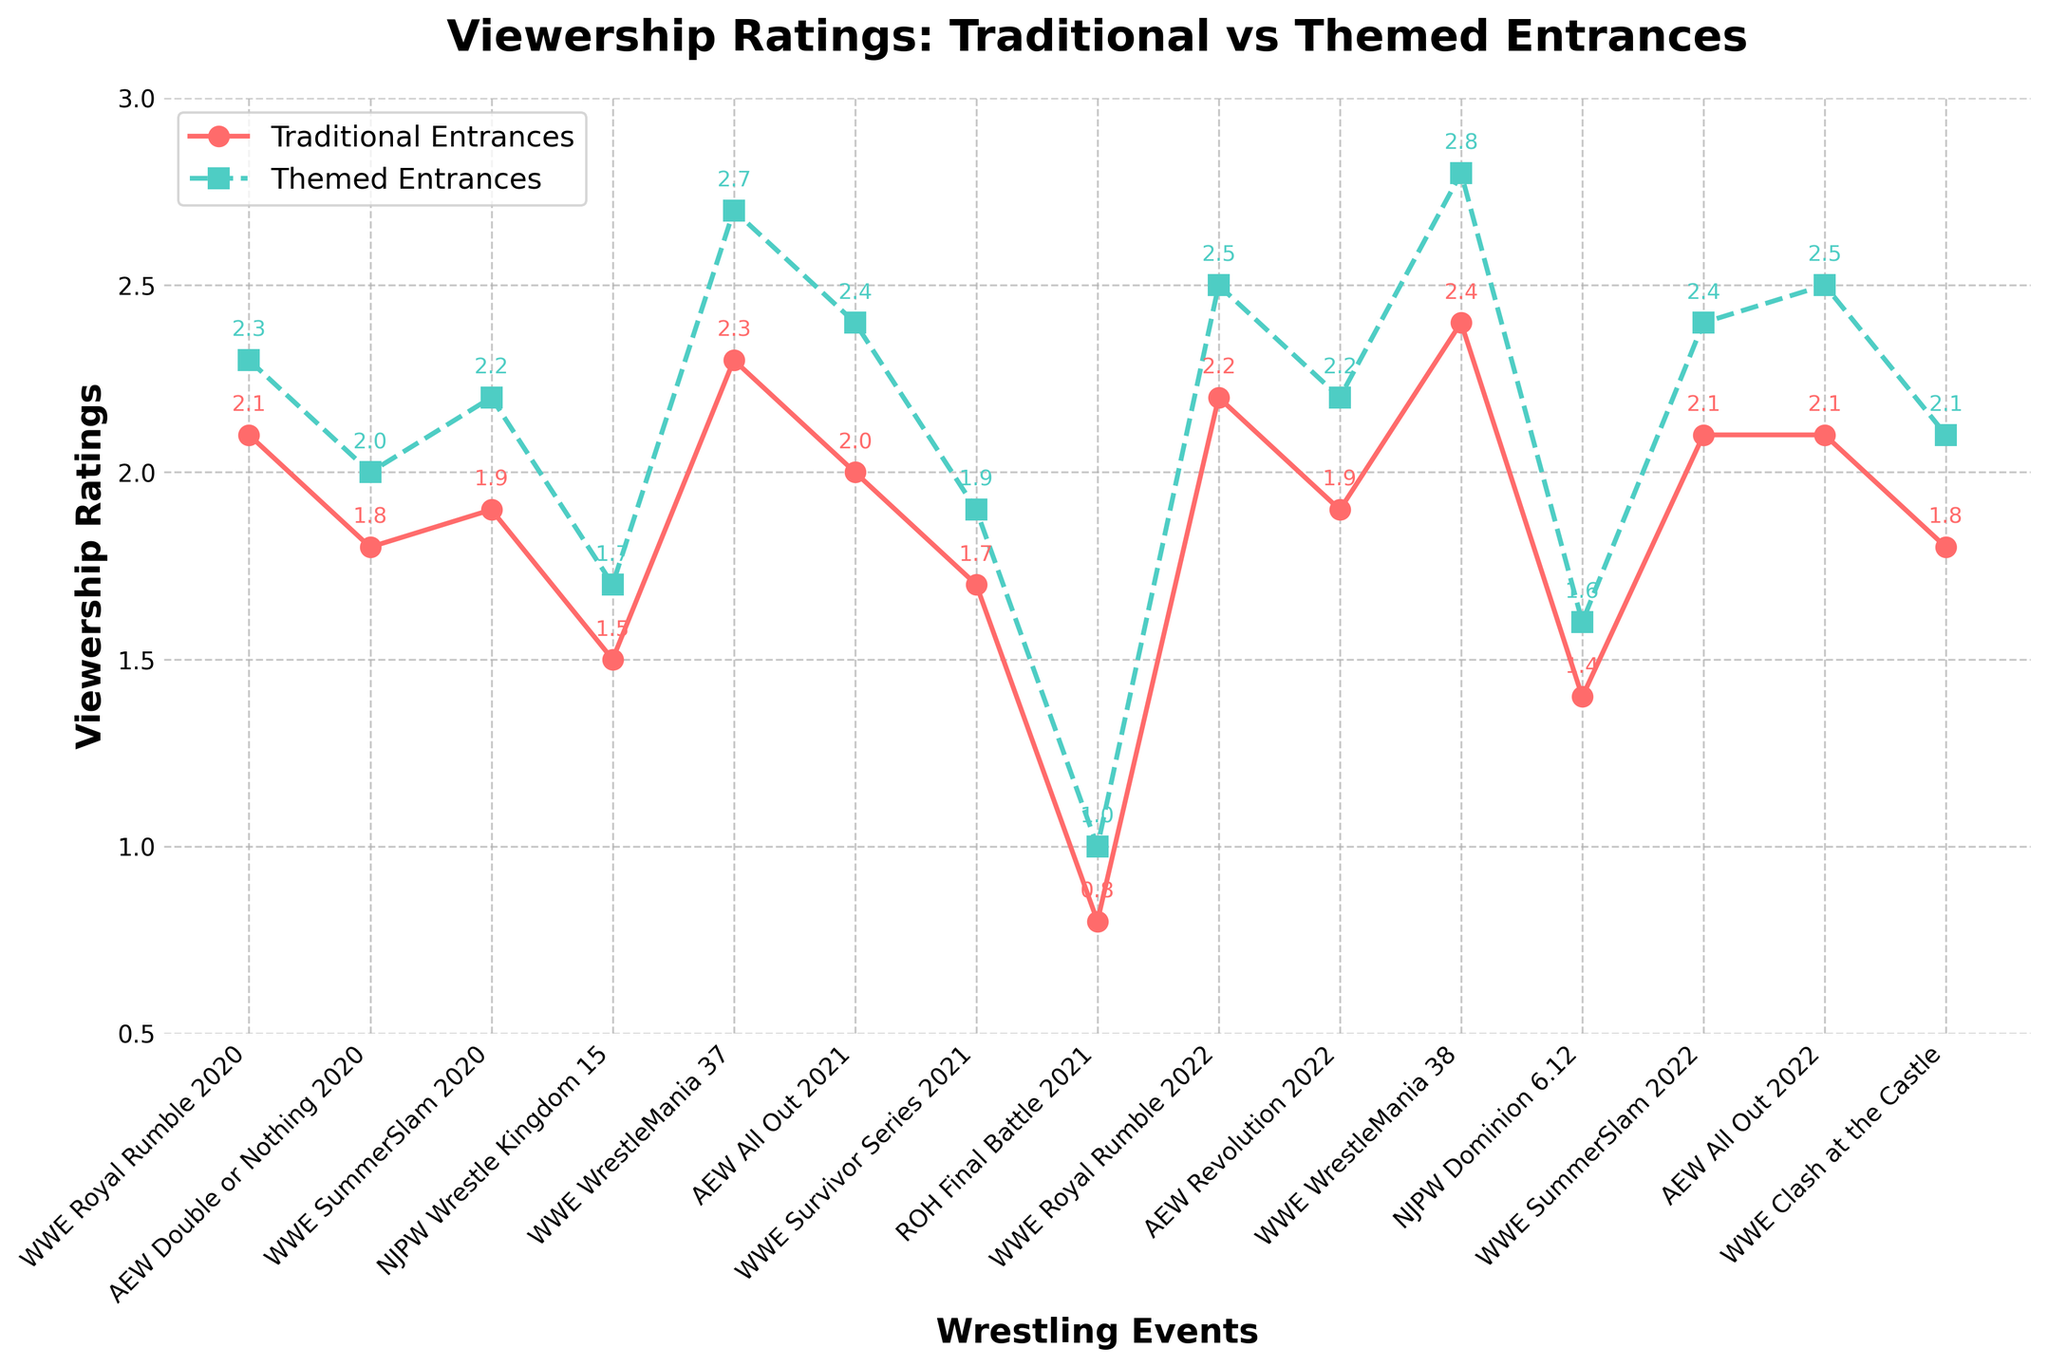Which event had the highest viewership rating for themed entrances? To find the event with the highest viewership rating for themed entrances, look at the green line representing themed entrances and identify the peak value. WWE WrestleMania 38 has the highest rating of 2.8.
Answer: WWE WrestleMania 38 What is the average viewership rating for traditional entrances across all events? Sum all the viewership ratings for traditional entrances and divide by the number of events. (2.1 + 1.8 + 1.9 + 1.5 + 2.3 + 2.0 + 1.7 + 0.8 + 2.2 + 1.9 + 2.4 + 1.4 + 2.1 + 2.1 + 1.8) / 15 = 1.93.
Answer: 1.93 Which event had the smallest difference in viewership ratings between traditional and themed entrances? Calculate the difference for each event and determine which one is the smallest: WWE Royal Rumble 2020 (0.2), AEW Double or Nothing 2020 (0.2), WWE SummerSlam 2020 (0.3), NJPW Wrestle Kingdom 15 (0.2), WWE WrestleMania 37 (0.4), AEW All Out 2021 (0.4), WWE Survivor Series 2021 (0.2), ROH Final Battle 2021 (0.2), WWE Royal Rumble 2022 (0.3), AEW Revolution 2022 (0.3), WWE WrestleMania 38 (0.4), NJPW Dominion 6.12 (0.2), WWE SummerSlam 2022 (0.3), AEW All Out 2022 (0.4), WWE Clash at the Castle (0.3). The smallest differences are 0.2, shared by multiple events.
Answer: WWE Royal Rumble 2020, AEW Double or Nothing 2020, NJPW Wrestle Kingdom 15, WWE Survivor Series 2021, ROH Final Battle 2021, NJPW Dominion 6.12 Describe the trend of viewership ratings for WWE Royal Rumble events over the years. Look at the points on the line chart for WWE Royal Rumble 2020 and WWE Royal Rumble 2022. Ratings for traditional entrances increased from 2.1 to 2.2, and for themed entrances from 2.3 to 2.5.
Answer: Increasing Which event had the lowest viewership rating for traditional entrances? Look for the red line that reaches the lowest point. ROH Final Battle 2021 has the lowest rating for traditional entrances at 0.8.
Answer: ROH Final Battle 2021 Are the viewership ratings for themed entrances generally higher than for traditional entrances? Compare the trend lines. The green line representing themed entrances is consistently above the red line for traditional entrances, indicating that themed entrances generally have higher ratings.
Answer: Yes 